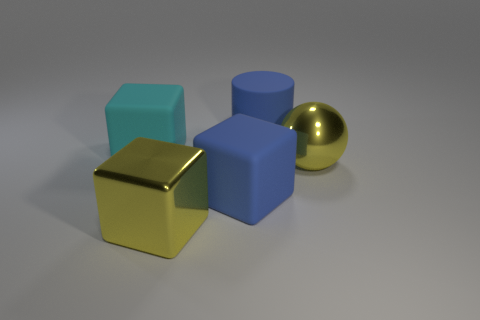How many large blue things are the same shape as the cyan rubber thing?
Provide a succinct answer. 1. There is a blue thing that is the same shape as the cyan matte thing; what is its material?
Your response must be concise. Rubber. Does the ball have the same material as the blue block?
Ensure brevity in your answer.  No. What is the big cube behind the yellow thing that is behind the yellow block made of?
Make the answer very short. Rubber. How many large things are brown cylinders or yellow metallic spheres?
Your answer should be compact. 1. How big is the blue cylinder?
Keep it short and to the point. Large. Are there more objects on the left side of the matte cylinder than large blue rubber objects?
Your answer should be compact. Yes. Are there an equal number of metal cubes behind the blue rubber cylinder and things on the left side of the yellow ball?
Your answer should be very brief. No. What is the color of the rubber thing that is both behind the ball and right of the big cyan block?
Provide a short and direct response. Blue. Are there any other things that have the same size as the blue rubber cylinder?
Make the answer very short. Yes. 